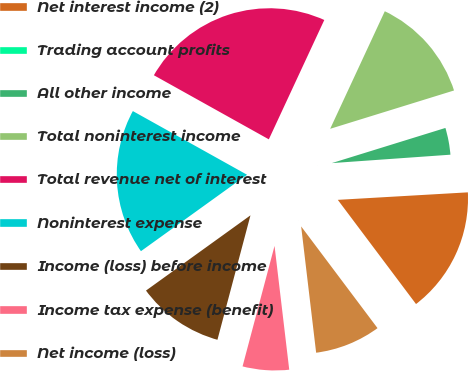Convert chart to OTSL. <chart><loc_0><loc_0><loc_500><loc_500><pie_chart><fcel>Net interest income (2)<fcel>Trading account profits<fcel>All other income<fcel>Total noninterest income<fcel>Total revenue net of interest<fcel>Noninterest expense<fcel>Income (loss) before income<fcel>Income tax expense (benefit)<fcel>Net income (loss)<nl><fcel>15.67%<fcel>0.21%<fcel>3.65%<fcel>13.3%<fcel>23.83%<fcel>18.03%<fcel>10.94%<fcel>6.01%<fcel>8.37%<nl></chart> 